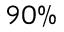Convert formula to latex. <formula><loc_0><loc_0><loc_500><loc_500>9 0 \%</formula> 